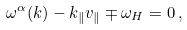Convert formula to latex. <formula><loc_0><loc_0><loc_500><loc_500>\omega ^ { \alpha } ( { k } ) - k _ { \| } v _ { \| } \mp \omega _ { H } = 0 \, ,</formula> 